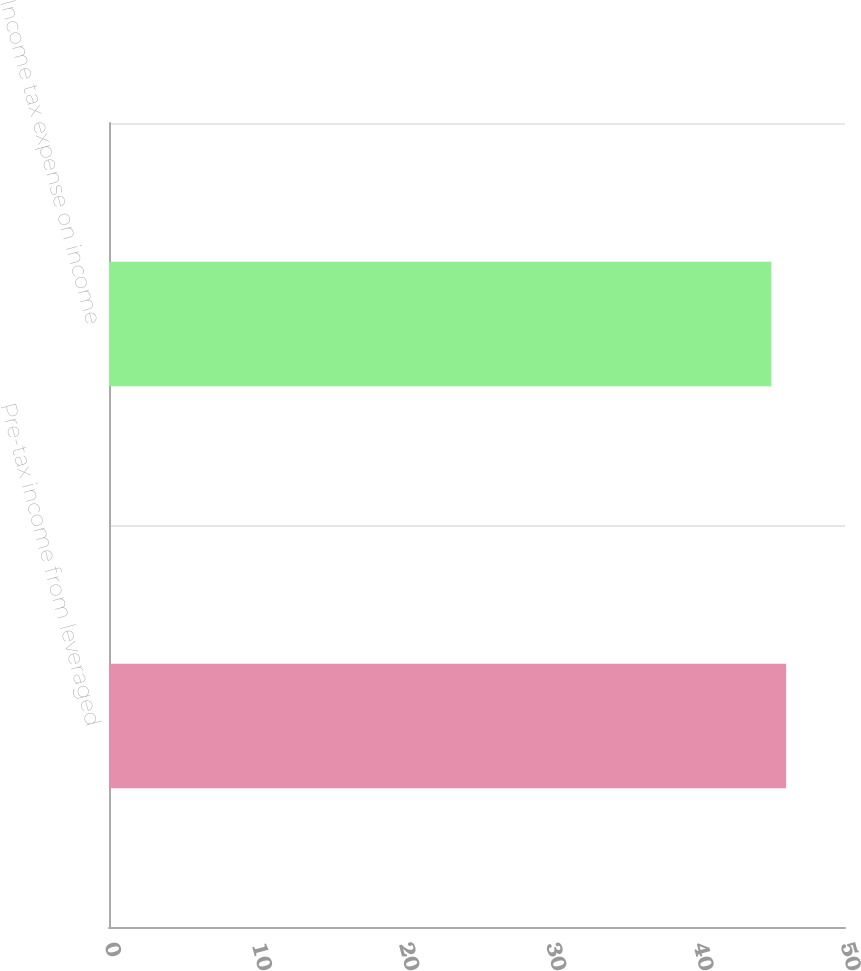Convert chart. <chart><loc_0><loc_0><loc_500><loc_500><bar_chart><fcel>Pre-tax income from leveraged<fcel>Income tax expense on income<nl><fcel>46<fcel>45<nl></chart> 